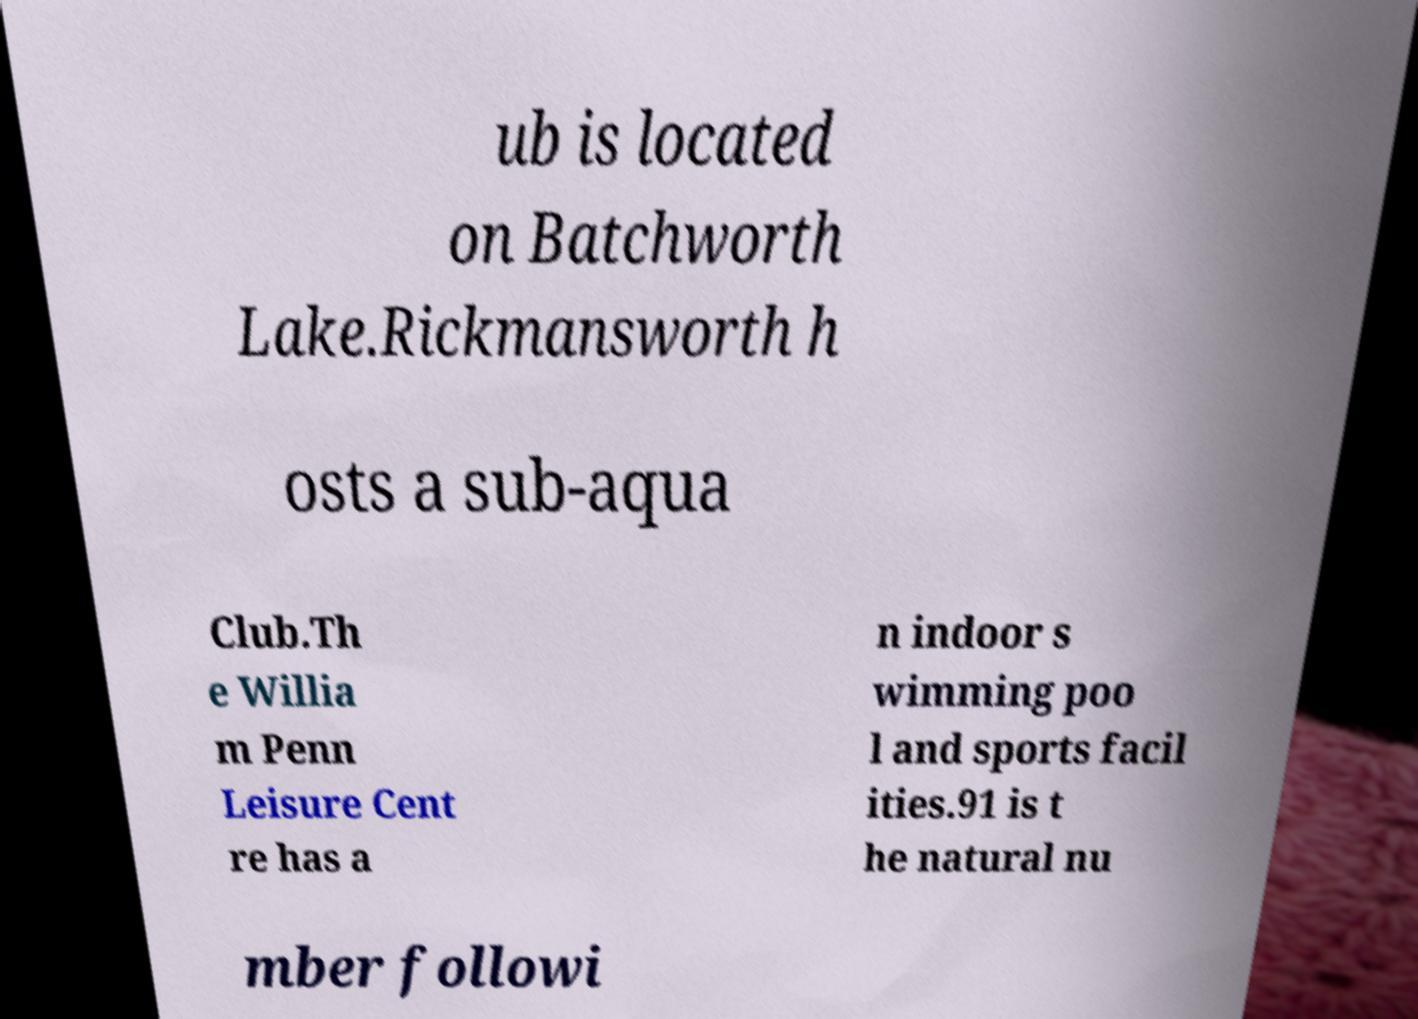What messages or text are displayed in this image? I need them in a readable, typed format. ub is located on Batchworth Lake.Rickmansworth h osts a sub-aqua Club.Th e Willia m Penn Leisure Cent re has a n indoor s wimming poo l and sports facil ities.91 is t he natural nu mber followi 